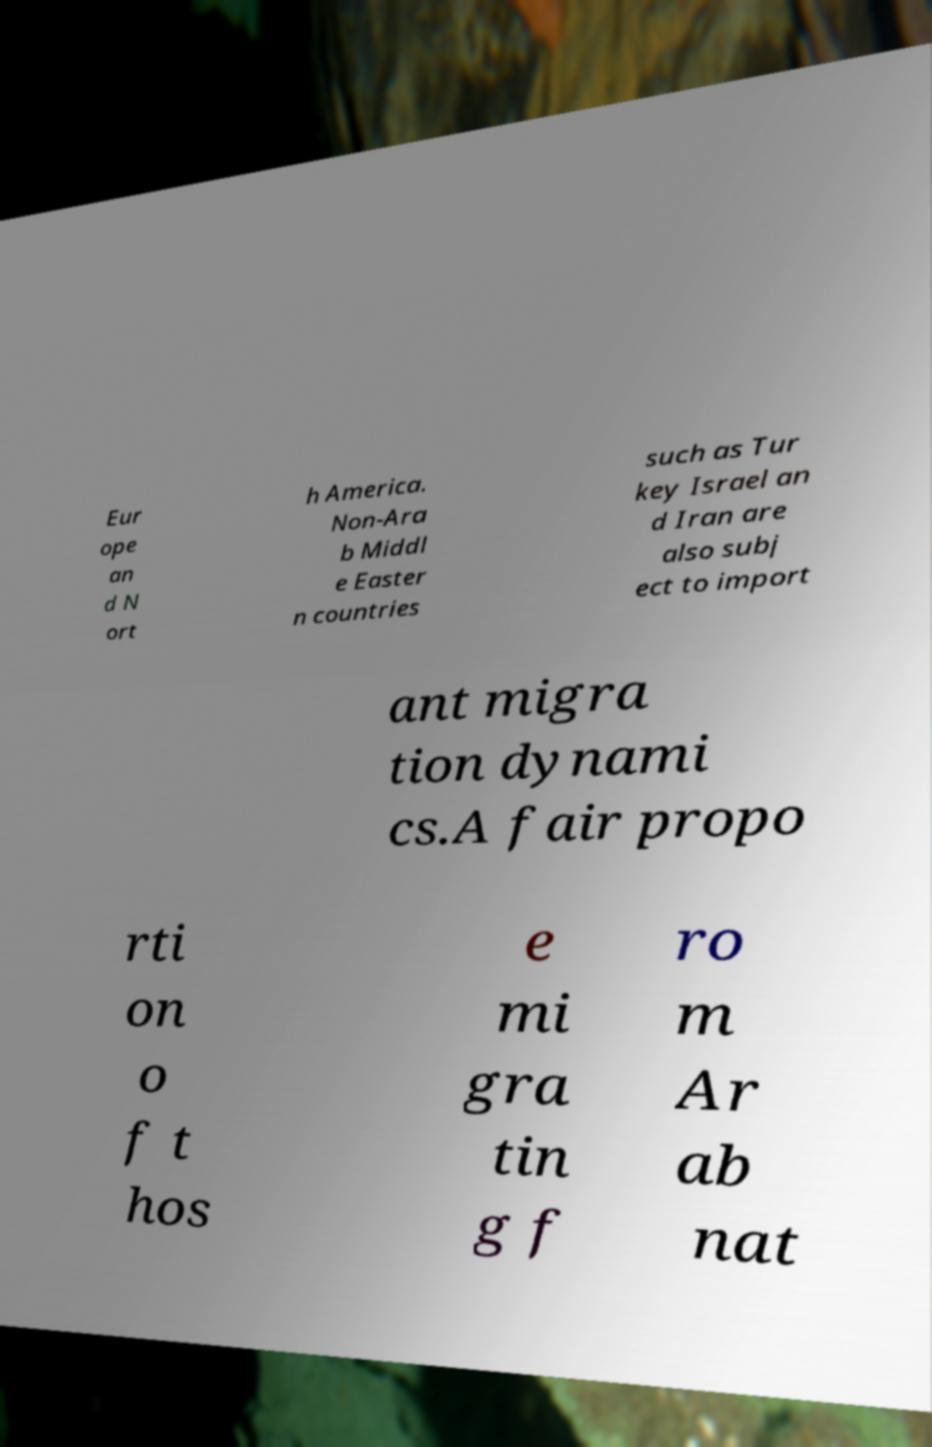I need the written content from this picture converted into text. Can you do that? Eur ope an d N ort h America. Non-Ara b Middl e Easter n countries such as Tur key Israel an d Iran are also subj ect to import ant migra tion dynami cs.A fair propo rti on o f t hos e mi gra tin g f ro m Ar ab nat 